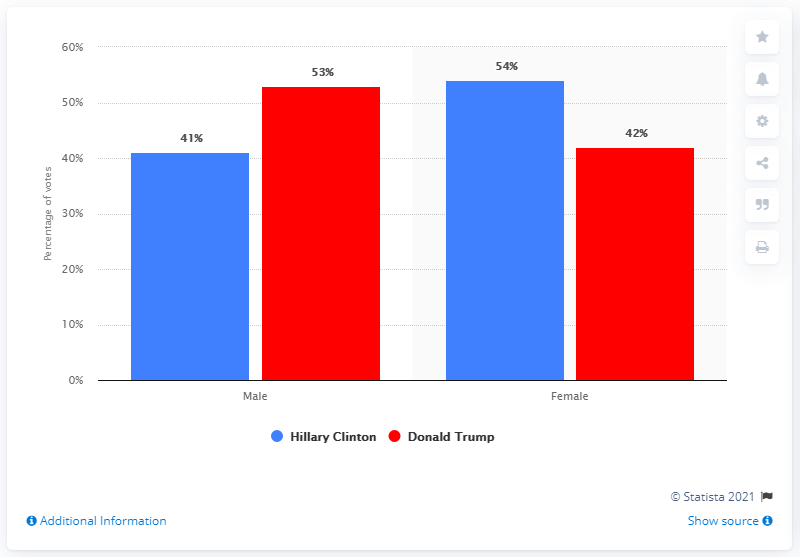Outline some significant characteristics in this image. According to the data, 41% of male voters supported Hillary Clinton during the 2016 election. In the election between Clinton and Trump, a smaller percentage of males voted for Clinton compared to Trump. Specifically, Clinton received support from 13% fewer male voters than Trump. 